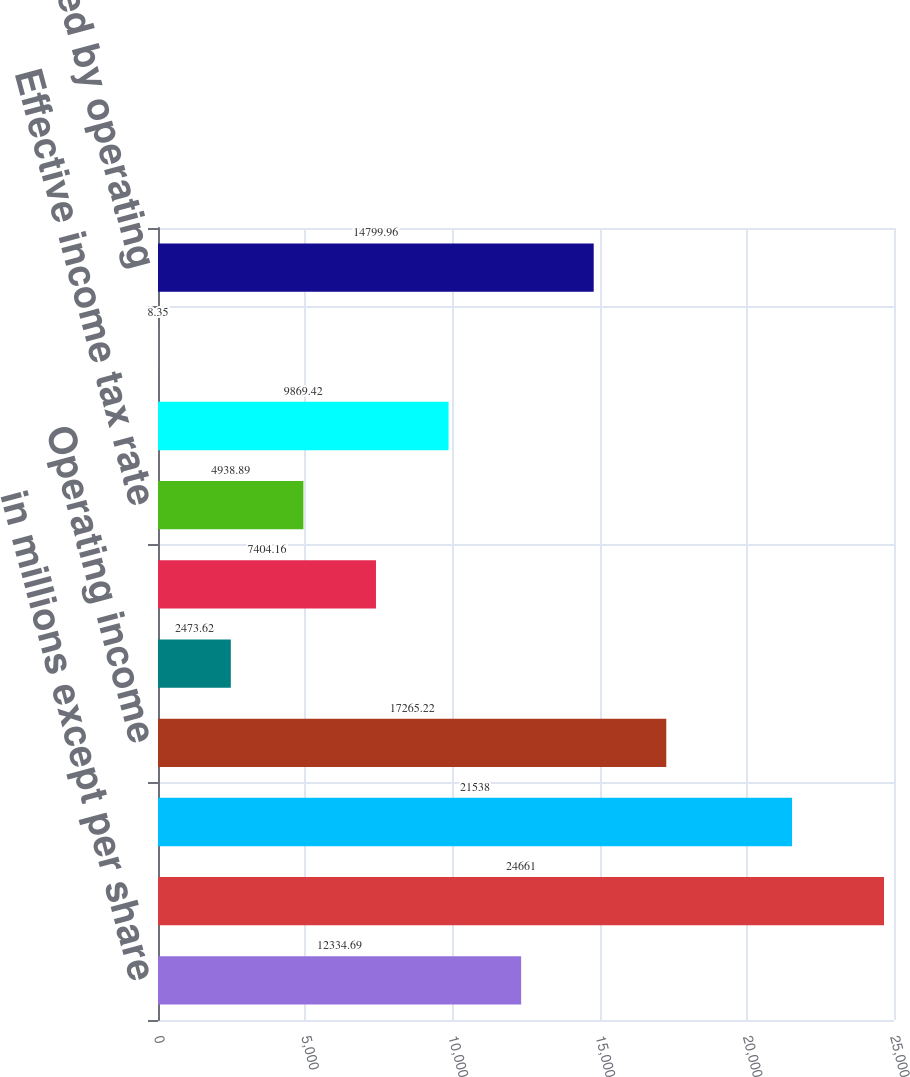<chart> <loc_0><loc_0><loc_500><loc_500><bar_chart><fcel>in millions except per share<fcel>Sales<fcel>Operating costs and expenses<fcel>Operating income<fcel>Operating margin rate<fcel>Federal and foreign income tax<fcel>Effective income tax rate<fcel>Net earnings<fcel>Diluted earnings per share<fcel>Net cash provided by operating<nl><fcel>12334.7<fcel>24661<fcel>21538<fcel>17265.2<fcel>2473.62<fcel>7404.16<fcel>4938.89<fcel>9869.42<fcel>8.35<fcel>14800<nl></chart> 